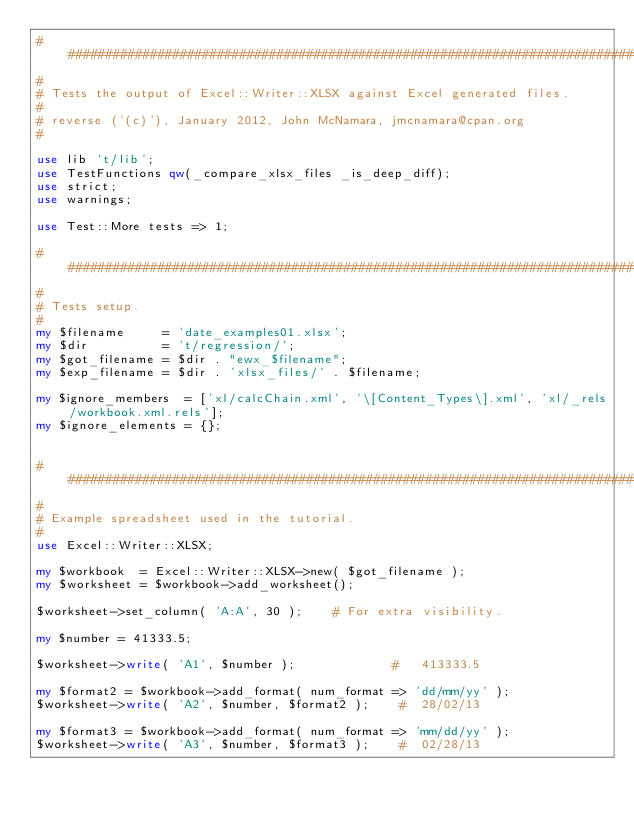Convert code to text. <code><loc_0><loc_0><loc_500><loc_500><_Perl_>###############################################################################
#
# Tests the output of Excel::Writer::XLSX against Excel generated files.
#
# reverse ('(c)'), January 2012, John McNamara, jmcnamara@cpan.org
#

use lib 't/lib';
use TestFunctions qw(_compare_xlsx_files _is_deep_diff);
use strict;
use warnings;

use Test::More tests => 1;

###############################################################################
#
# Tests setup.
#
my $filename     = 'date_examples01.xlsx';
my $dir          = 't/regression/';
my $got_filename = $dir . "ewx_$filename";
my $exp_filename = $dir . 'xlsx_files/' . $filename;

my $ignore_members  = ['xl/calcChain.xml', '\[Content_Types\].xml', 'xl/_rels/workbook.xml.rels'];
my $ignore_elements = {};


###############################################################################
#
# Example spreadsheet used in the tutorial.
#
use Excel::Writer::XLSX;

my $workbook  = Excel::Writer::XLSX->new( $got_filename );
my $worksheet = $workbook->add_worksheet();

$worksheet->set_column( 'A:A', 30 );    # For extra visibility.

my $number = 41333.5;

$worksheet->write( 'A1', $number );             #   413333.5

my $format2 = $workbook->add_format( num_format => 'dd/mm/yy' );
$worksheet->write( 'A2', $number, $format2 );    #  28/02/13

my $format3 = $workbook->add_format( num_format => 'mm/dd/yy' );
$worksheet->write( 'A3', $number, $format3 );    #  02/28/13
</code> 